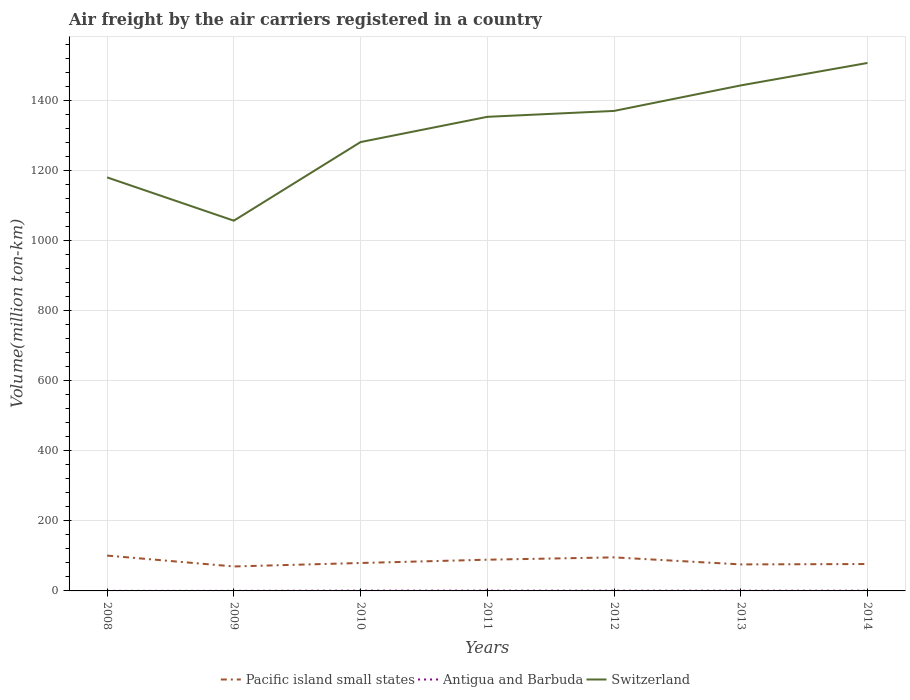Does the line corresponding to Switzerland intersect with the line corresponding to Antigua and Barbuda?
Your answer should be compact. No. Across all years, what is the maximum volume of the air carriers in Switzerland?
Provide a short and direct response. 1057.89. What is the total volume of the air carriers in Switzerland in the graph?
Your answer should be very brief. -100.93. What is the difference between the highest and the second highest volume of the air carriers in Switzerland?
Your response must be concise. 450.6. Is the volume of the air carriers in Antigua and Barbuda strictly greater than the volume of the air carriers in Switzerland over the years?
Your response must be concise. Yes. How many lines are there?
Your answer should be very brief. 3. How many legend labels are there?
Make the answer very short. 3. What is the title of the graph?
Keep it short and to the point. Air freight by the air carriers registered in a country. What is the label or title of the X-axis?
Your response must be concise. Years. What is the label or title of the Y-axis?
Provide a succinct answer. Volume(million ton-km). What is the Volume(million ton-km) in Pacific island small states in 2008?
Give a very brief answer. 100.99. What is the Volume(million ton-km) in Antigua and Barbuda in 2008?
Offer a very short reply. 0.19. What is the Volume(million ton-km) of Switzerland in 2008?
Offer a terse response. 1181.57. What is the Volume(million ton-km) in Pacific island small states in 2009?
Your answer should be very brief. 69.89. What is the Volume(million ton-km) of Antigua and Barbuda in 2009?
Your answer should be very brief. 0.17. What is the Volume(million ton-km) of Switzerland in 2009?
Your response must be concise. 1057.89. What is the Volume(million ton-km) in Pacific island small states in 2010?
Make the answer very short. 79.81. What is the Volume(million ton-km) of Antigua and Barbuda in 2010?
Your answer should be compact. 0.79. What is the Volume(million ton-km) in Switzerland in 2010?
Provide a short and direct response. 1282.5. What is the Volume(million ton-km) in Pacific island small states in 2011?
Make the answer very short. 89.19. What is the Volume(million ton-km) of Antigua and Barbuda in 2011?
Keep it short and to the point. 0.74. What is the Volume(million ton-km) of Switzerland in 2011?
Offer a very short reply. 1354.59. What is the Volume(million ton-km) in Pacific island small states in 2012?
Keep it short and to the point. 95.87. What is the Volume(million ton-km) of Antigua and Barbuda in 2012?
Offer a terse response. 0.65. What is the Volume(million ton-km) of Switzerland in 2012?
Provide a short and direct response. 1371.47. What is the Volume(million ton-km) of Pacific island small states in 2013?
Your answer should be compact. 75.74. What is the Volume(million ton-km) in Antigua and Barbuda in 2013?
Offer a terse response. 0.59. What is the Volume(million ton-km) in Switzerland in 2013?
Ensure brevity in your answer.  1444.37. What is the Volume(million ton-km) in Pacific island small states in 2014?
Make the answer very short. 76.83. What is the Volume(million ton-km) in Antigua and Barbuda in 2014?
Your answer should be very brief. 0.59. What is the Volume(million ton-km) of Switzerland in 2014?
Offer a very short reply. 1508.5. Across all years, what is the maximum Volume(million ton-km) of Pacific island small states?
Provide a succinct answer. 100.99. Across all years, what is the maximum Volume(million ton-km) of Antigua and Barbuda?
Your answer should be very brief. 0.79. Across all years, what is the maximum Volume(million ton-km) in Switzerland?
Give a very brief answer. 1508.5. Across all years, what is the minimum Volume(million ton-km) of Pacific island small states?
Offer a very short reply. 69.89. Across all years, what is the minimum Volume(million ton-km) of Antigua and Barbuda?
Ensure brevity in your answer.  0.17. Across all years, what is the minimum Volume(million ton-km) in Switzerland?
Your answer should be very brief. 1057.89. What is the total Volume(million ton-km) of Pacific island small states in the graph?
Give a very brief answer. 588.33. What is the total Volume(million ton-km) in Antigua and Barbuda in the graph?
Offer a terse response. 3.71. What is the total Volume(million ton-km) of Switzerland in the graph?
Your answer should be very brief. 9200.89. What is the difference between the Volume(million ton-km) in Pacific island small states in 2008 and that in 2009?
Offer a very short reply. 31.1. What is the difference between the Volume(million ton-km) in Antigua and Barbuda in 2008 and that in 2009?
Offer a terse response. 0.03. What is the difference between the Volume(million ton-km) in Switzerland in 2008 and that in 2009?
Keep it short and to the point. 123.67. What is the difference between the Volume(million ton-km) of Pacific island small states in 2008 and that in 2010?
Your answer should be very brief. 21.19. What is the difference between the Volume(million ton-km) of Antigua and Barbuda in 2008 and that in 2010?
Give a very brief answer. -0.59. What is the difference between the Volume(million ton-km) of Switzerland in 2008 and that in 2010?
Keep it short and to the point. -100.93. What is the difference between the Volume(million ton-km) in Pacific island small states in 2008 and that in 2011?
Provide a short and direct response. 11.8. What is the difference between the Volume(million ton-km) of Antigua and Barbuda in 2008 and that in 2011?
Provide a short and direct response. -0.54. What is the difference between the Volume(million ton-km) in Switzerland in 2008 and that in 2011?
Keep it short and to the point. -173.02. What is the difference between the Volume(million ton-km) in Pacific island small states in 2008 and that in 2012?
Give a very brief answer. 5.12. What is the difference between the Volume(million ton-km) of Antigua and Barbuda in 2008 and that in 2012?
Keep it short and to the point. -0.45. What is the difference between the Volume(million ton-km) of Switzerland in 2008 and that in 2012?
Offer a terse response. -189.9. What is the difference between the Volume(million ton-km) of Pacific island small states in 2008 and that in 2013?
Offer a terse response. 25.25. What is the difference between the Volume(million ton-km) of Antigua and Barbuda in 2008 and that in 2013?
Your answer should be very brief. -0.4. What is the difference between the Volume(million ton-km) in Switzerland in 2008 and that in 2013?
Give a very brief answer. -262.81. What is the difference between the Volume(million ton-km) of Pacific island small states in 2008 and that in 2014?
Provide a succinct answer. 24.16. What is the difference between the Volume(million ton-km) in Antigua and Barbuda in 2008 and that in 2014?
Your answer should be very brief. -0.4. What is the difference between the Volume(million ton-km) of Switzerland in 2008 and that in 2014?
Make the answer very short. -326.93. What is the difference between the Volume(million ton-km) of Pacific island small states in 2009 and that in 2010?
Offer a terse response. -9.92. What is the difference between the Volume(million ton-km) of Antigua and Barbuda in 2009 and that in 2010?
Offer a very short reply. -0.62. What is the difference between the Volume(million ton-km) of Switzerland in 2009 and that in 2010?
Your answer should be very brief. -224.6. What is the difference between the Volume(million ton-km) of Pacific island small states in 2009 and that in 2011?
Your answer should be compact. -19.3. What is the difference between the Volume(million ton-km) of Antigua and Barbuda in 2009 and that in 2011?
Offer a very short reply. -0.57. What is the difference between the Volume(million ton-km) of Switzerland in 2009 and that in 2011?
Offer a terse response. -296.7. What is the difference between the Volume(million ton-km) in Pacific island small states in 2009 and that in 2012?
Your answer should be very brief. -25.98. What is the difference between the Volume(million ton-km) of Antigua and Barbuda in 2009 and that in 2012?
Your answer should be compact. -0.48. What is the difference between the Volume(million ton-km) of Switzerland in 2009 and that in 2012?
Your answer should be very brief. -313.58. What is the difference between the Volume(million ton-km) of Pacific island small states in 2009 and that in 2013?
Give a very brief answer. -5.85. What is the difference between the Volume(million ton-km) in Antigua and Barbuda in 2009 and that in 2013?
Offer a very short reply. -0.43. What is the difference between the Volume(million ton-km) of Switzerland in 2009 and that in 2013?
Provide a succinct answer. -386.48. What is the difference between the Volume(million ton-km) of Pacific island small states in 2009 and that in 2014?
Offer a very short reply. -6.94. What is the difference between the Volume(million ton-km) in Antigua and Barbuda in 2009 and that in 2014?
Your response must be concise. -0.43. What is the difference between the Volume(million ton-km) of Switzerland in 2009 and that in 2014?
Provide a succinct answer. -450.6. What is the difference between the Volume(million ton-km) of Pacific island small states in 2010 and that in 2011?
Provide a short and direct response. -9.38. What is the difference between the Volume(million ton-km) of Antigua and Barbuda in 2010 and that in 2011?
Your answer should be compact. 0.05. What is the difference between the Volume(million ton-km) of Switzerland in 2010 and that in 2011?
Your answer should be very brief. -72.09. What is the difference between the Volume(million ton-km) of Pacific island small states in 2010 and that in 2012?
Offer a terse response. -16.07. What is the difference between the Volume(million ton-km) of Antigua and Barbuda in 2010 and that in 2012?
Keep it short and to the point. 0.14. What is the difference between the Volume(million ton-km) in Switzerland in 2010 and that in 2012?
Your response must be concise. -88.97. What is the difference between the Volume(million ton-km) in Pacific island small states in 2010 and that in 2013?
Provide a short and direct response. 4.07. What is the difference between the Volume(million ton-km) of Antigua and Barbuda in 2010 and that in 2013?
Make the answer very short. 0.19. What is the difference between the Volume(million ton-km) in Switzerland in 2010 and that in 2013?
Give a very brief answer. -161.88. What is the difference between the Volume(million ton-km) in Pacific island small states in 2010 and that in 2014?
Give a very brief answer. 2.97. What is the difference between the Volume(million ton-km) in Antigua and Barbuda in 2010 and that in 2014?
Offer a terse response. 0.19. What is the difference between the Volume(million ton-km) of Switzerland in 2010 and that in 2014?
Make the answer very short. -226. What is the difference between the Volume(million ton-km) in Pacific island small states in 2011 and that in 2012?
Ensure brevity in your answer.  -6.68. What is the difference between the Volume(million ton-km) of Antigua and Barbuda in 2011 and that in 2012?
Your answer should be very brief. 0.09. What is the difference between the Volume(million ton-km) of Switzerland in 2011 and that in 2012?
Offer a terse response. -16.88. What is the difference between the Volume(million ton-km) in Pacific island small states in 2011 and that in 2013?
Ensure brevity in your answer.  13.45. What is the difference between the Volume(million ton-km) of Antigua and Barbuda in 2011 and that in 2013?
Provide a short and direct response. 0.15. What is the difference between the Volume(million ton-km) in Switzerland in 2011 and that in 2013?
Ensure brevity in your answer.  -89.78. What is the difference between the Volume(million ton-km) of Pacific island small states in 2011 and that in 2014?
Make the answer very short. 12.36. What is the difference between the Volume(million ton-km) in Antigua and Barbuda in 2011 and that in 2014?
Keep it short and to the point. 0.15. What is the difference between the Volume(million ton-km) in Switzerland in 2011 and that in 2014?
Your answer should be compact. -153.91. What is the difference between the Volume(million ton-km) of Pacific island small states in 2012 and that in 2013?
Your response must be concise. 20.13. What is the difference between the Volume(million ton-km) of Antigua and Barbuda in 2012 and that in 2013?
Your answer should be compact. 0.06. What is the difference between the Volume(million ton-km) of Switzerland in 2012 and that in 2013?
Offer a very short reply. -72.9. What is the difference between the Volume(million ton-km) in Pacific island small states in 2012 and that in 2014?
Provide a succinct answer. 19.04. What is the difference between the Volume(million ton-km) of Antigua and Barbuda in 2012 and that in 2014?
Provide a succinct answer. 0.06. What is the difference between the Volume(million ton-km) in Switzerland in 2012 and that in 2014?
Ensure brevity in your answer.  -137.03. What is the difference between the Volume(million ton-km) of Pacific island small states in 2013 and that in 2014?
Make the answer very short. -1.09. What is the difference between the Volume(million ton-km) in Antigua and Barbuda in 2013 and that in 2014?
Make the answer very short. 0. What is the difference between the Volume(million ton-km) in Switzerland in 2013 and that in 2014?
Your answer should be very brief. -64.12. What is the difference between the Volume(million ton-km) in Pacific island small states in 2008 and the Volume(million ton-km) in Antigua and Barbuda in 2009?
Provide a succinct answer. 100.83. What is the difference between the Volume(million ton-km) in Pacific island small states in 2008 and the Volume(million ton-km) in Switzerland in 2009?
Give a very brief answer. -956.9. What is the difference between the Volume(million ton-km) of Antigua and Barbuda in 2008 and the Volume(million ton-km) of Switzerland in 2009?
Offer a terse response. -1057.7. What is the difference between the Volume(million ton-km) in Pacific island small states in 2008 and the Volume(million ton-km) in Antigua and Barbuda in 2010?
Give a very brief answer. 100.21. What is the difference between the Volume(million ton-km) in Pacific island small states in 2008 and the Volume(million ton-km) in Switzerland in 2010?
Your answer should be very brief. -1181.5. What is the difference between the Volume(million ton-km) in Antigua and Barbuda in 2008 and the Volume(million ton-km) in Switzerland in 2010?
Keep it short and to the point. -1282.3. What is the difference between the Volume(million ton-km) in Pacific island small states in 2008 and the Volume(million ton-km) in Antigua and Barbuda in 2011?
Offer a terse response. 100.26. What is the difference between the Volume(million ton-km) in Pacific island small states in 2008 and the Volume(million ton-km) in Switzerland in 2011?
Provide a succinct answer. -1253.6. What is the difference between the Volume(million ton-km) of Antigua and Barbuda in 2008 and the Volume(million ton-km) of Switzerland in 2011?
Your answer should be very brief. -1354.4. What is the difference between the Volume(million ton-km) in Pacific island small states in 2008 and the Volume(million ton-km) in Antigua and Barbuda in 2012?
Keep it short and to the point. 100.35. What is the difference between the Volume(million ton-km) in Pacific island small states in 2008 and the Volume(million ton-km) in Switzerland in 2012?
Ensure brevity in your answer.  -1270.48. What is the difference between the Volume(million ton-km) in Antigua and Barbuda in 2008 and the Volume(million ton-km) in Switzerland in 2012?
Make the answer very short. -1371.28. What is the difference between the Volume(million ton-km) in Pacific island small states in 2008 and the Volume(million ton-km) in Antigua and Barbuda in 2013?
Make the answer very short. 100.4. What is the difference between the Volume(million ton-km) in Pacific island small states in 2008 and the Volume(million ton-km) in Switzerland in 2013?
Offer a very short reply. -1343.38. What is the difference between the Volume(million ton-km) in Antigua and Barbuda in 2008 and the Volume(million ton-km) in Switzerland in 2013?
Give a very brief answer. -1444.18. What is the difference between the Volume(million ton-km) in Pacific island small states in 2008 and the Volume(million ton-km) in Antigua and Barbuda in 2014?
Keep it short and to the point. 100.4. What is the difference between the Volume(million ton-km) in Pacific island small states in 2008 and the Volume(million ton-km) in Switzerland in 2014?
Give a very brief answer. -1407.5. What is the difference between the Volume(million ton-km) of Antigua and Barbuda in 2008 and the Volume(million ton-km) of Switzerland in 2014?
Your response must be concise. -1508.3. What is the difference between the Volume(million ton-km) in Pacific island small states in 2009 and the Volume(million ton-km) in Antigua and Barbuda in 2010?
Offer a terse response. 69.11. What is the difference between the Volume(million ton-km) in Pacific island small states in 2009 and the Volume(million ton-km) in Switzerland in 2010?
Keep it short and to the point. -1212.61. What is the difference between the Volume(million ton-km) in Antigua and Barbuda in 2009 and the Volume(million ton-km) in Switzerland in 2010?
Make the answer very short. -1282.33. What is the difference between the Volume(million ton-km) of Pacific island small states in 2009 and the Volume(million ton-km) of Antigua and Barbuda in 2011?
Give a very brief answer. 69.15. What is the difference between the Volume(million ton-km) of Pacific island small states in 2009 and the Volume(million ton-km) of Switzerland in 2011?
Keep it short and to the point. -1284.7. What is the difference between the Volume(million ton-km) in Antigua and Barbuda in 2009 and the Volume(million ton-km) in Switzerland in 2011?
Provide a short and direct response. -1354.43. What is the difference between the Volume(million ton-km) in Pacific island small states in 2009 and the Volume(million ton-km) in Antigua and Barbuda in 2012?
Your answer should be very brief. 69.24. What is the difference between the Volume(million ton-km) of Pacific island small states in 2009 and the Volume(million ton-km) of Switzerland in 2012?
Give a very brief answer. -1301.58. What is the difference between the Volume(million ton-km) in Antigua and Barbuda in 2009 and the Volume(million ton-km) in Switzerland in 2012?
Your response must be concise. -1371.31. What is the difference between the Volume(million ton-km) in Pacific island small states in 2009 and the Volume(million ton-km) in Antigua and Barbuda in 2013?
Ensure brevity in your answer.  69.3. What is the difference between the Volume(million ton-km) in Pacific island small states in 2009 and the Volume(million ton-km) in Switzerland in 2013?
Your answer should be compact. -1374.48. What is the difference between the Volume(million ton-km) in Antigua and Barbuda in 2009 and the Volume(million ton-km) in Switzerland in 2013?
Make the answer very short. -1444.21. What is the difference between the Volume(million ton-km) of Pacific island small states in 2009 and the Volume(million ton-km) of Antigua and Barbuda in 2014?
Your response must be concise. 69.3. What is the difference between the Volume(million ton-km) in Pacific island small states in 2009 and the Volume(million ton-km) in Switzerland in 2014?
Your answer should be very brief. -1438.61. What is the difference between the Volume(million ton-km) in Antigua and Barbuda in 2009 and the Volume(million ton-km) in Switzerland in 2014?
Give a very brief answer. -1508.33. What is the difference between the Volume(million ton-km) in Pacific island small states in 2010 and the Volume(million ton-km) in Antigua and Barbuda in 2011?
Ensure brevity in your answer.  79.07. What is the difference between the Volume(million ton-km) in Pacific island small states in 2010 and the Volume(million ton-km) in Switzerland in 2011?
Give a very brief answer. -1274.78. What is the difference between the Volume(million ton-km) in Antigua and Barbuda in 2010 and the Volume(million ton-km) in Switzerland in 2011?
Offer a terse response. -1353.81. What is the difference between the Volume(million ton-km) in Pacific island small states in 2010 and the Volume(million ton-km) in Antigua and Barbuda in 2012?
Your answer should be very brief. 79.16. What is the difference between the Volume(million ton-km) in Pacific island small states in 2010 and the Volume(million ton-km) in Switzerland in 2012?
Offer a very short reply. -1291.66. What is the difference between the Volume(million ton-km) of Antigua and Barbuda in 2010 and the Volume(million ton-km) of Switzerland in 2012?
Ensure brevity in your answer.  -1370.69. What is the difference between the Volume(million ton-km) in Pacific island small states in 2010 and the Volume(million ton-km) in Antigua and Barbuda in 2013?
Offer a terse response. 79.21. What is the difference between the Volume(million ton-km) of Pacific island small states in 2010 and the Volume(million ton-km) of Switzerland in 2013?
Make the answer very short. -1364.57. What is the difference between the Volume(million ton-km) in Antigua and Barbuda in 2010 and the Volume(million ton-km) in Switzerland in 2013?
Offer a very short reply. -1443.59. What is the difference between the Volume(million ton-km) of Pacific island small states in 2010 and the Volume(million ton-km) of Antigua and Barbuda in 2014?
Offer a terse response. 79.22. What is the difference between the Volume(million ton-km) of Pacific island small states in 2010 and the Volume(million ton-km) of Switzerland in 2014?
Give a very brief answer. -1428.69. What is the difference between the Volume(million ton-km) in Antigua and Barbuda in 2010 and the Volume(million ton-km) in Switzerland in 2014?
Offer a very short reply. -1507.71. What is the difference between the Volume(million ton-km) in Pacific island small states in 2011 and the Volume(million ton-km) in Antigua and Barbuda in 2012?
Your answer should be very brief. 88.54. What is the difference between the Volume(million ton-km) in Pacific island small states in 2011 and the Volume(million ton-km) in Switzerland in 2012?
Offer a very short reply. -1282.28. What is the difference between the Volume(million ton-km) in Antigua and Barbuda in 2011 and the Volume(million ton-km) in Switzerland in 2012?
Your answer should be very brief. -1370.73. What is the difference between the Volume(million ton-km) of Pacific island small states in 2011 and the Volume(million ton-km) of Antigua and Barbuda in 2013?
Offer a terse response. 88.6. What is the difference between the Volume(million ton-km) of Pacific island small states in 2011 and the Volume(million ton-km) of Switzerland in 2013?
Offer a very short reply. -1355.18. What is the difference between the Volume(million ton-km) of Antigua and Barbuda in 2011 and the Volume(million ton-km) of Switzerland in 2013?
Offer a very short reply. -1443.64. What is the difference between the Volume(million ton-km) in Pacific island small states in 2011 and the Volume(million ton-km) in Antigua and Barbuda in 2014?
Ensure brevity in your answer.  88.6. What is the difference between the Volume(million ton-km) of Pacific island small states in 2011 and the Volume(million ton-km) of Switzerland in 2014?
Ensure brevity in your answer.  -1419.31. What is the difference between the Volume(million ton-km) of Antigua and Barbuda in 2011 and the Volume(million ton-km) of Switzerland in 2014?
Provide a short and direct response. -1507.76. What is the difference between the Volume(million ton-km) of Pacific island small states in 2012 and the Volume(million ton-km) of Antigua and Barbuda in 2013?
Offer a very short reply. 95.28. What is the difference between the Volume(million ton-km) of Pacific island small states in 2012 and the Volume(million ton-km) of Switzerland in 2013?
Provide a short and direct response. -1348.5. What is the difference between the Volume(million ton-km) of Antigua and Barbuda in 2012 and the Volume(million ton-km) of Switzerland in 2013?
Provide a succinct answer. -1443.73. What is the difference between the Volume(million ton-km) of Pacific island small states in 2012 and the Volume(million ton-km) of Antigua and Barbuda in 2014?
Offer a terse response. 95.28. What is the difference between the Volume(million ton-km) of Pacific island small states in 2012 and the Volume(million ton-km) of Switzerland in 2014?
Make the answer very short. -1412.62. What is the difference between the Volume(million ton-km) of Antigua and Barbuda in 2012 and the Volume(million ton-km) of Switzerland in 2014?
Offer a terse response. -1507.85. What is the difference between the Volume(million ton-km) of Pacific island small states in 2013 and the Volume(million ton-km) of Antigua and Barbuda in 2014?
Offer a terse response. 75.15. What is the difference between the Volume(million ton-km) of Pacific island small states in 2013 and the Volume(million ton-km) of Switzerland in 2014?
Your answer should be compact. -1432.75. What is the difference between the Volume(million ton-km) of Antigua and Barbuda in 2013 and the Volume(million ton-km) of Switzerland in 2014?
Give a very brief answer. -1507.9. What is the average Volume(million ton-km) in Pacific island small states per year?
Your response must be concise. 84.05. What is the average Volume(million ton-km) of Antigua and Barbuda per year?
Your response must be concise. 0.53. What is the average Volume(million ton-km) of Switzerland per year?
Provide a short and direct response. 1314.41. In the year 2008, what is the difference between the Volume(million ton-km) in Pacific island small states and Volume(million ton-km) in Antigua and Barbuda?
Offer a terse response. 100.8. In the year 2008, what is the difference between the Volume(million ton-km) in Pacific island small states and Volume(million ton-km) in Switzerland?
Give a very brief answer. -1080.57. In the year 2008, what is the difference between the Volume(million ton-km) of Antigua and Barbuda and Volume(million ton-km) of Switzerland?
Ensure brevity in your answer.  -1181.37. In the year 2009, what is the difference between the Volume(million ton-km) of Pacific island small states and Volume(million ton-km) of Antigua and Barbuda?
Give a very brief answer. 69.73. In the year 2009, what is the difference between the Volume(million ton-km) in Pacific island small states and Volume(million ton-km) in Switzerland?
Offer a terse response. -988. In the year 2009, what is the difference between the Volume(million ton-km) of Antigua and Barbuda and Volume(million ton-km) of Switzerland?
Your answer should be compact. -1057.73. In the year 2010, what is the difference between the Volume(million ton-km) in Pacific island small states and Volume(million ton-km) in Antigua and Barbuda?
Offer a terse response. 79.02. In the year 2010, what is the difference between the Volume(million ton-km) in Pacific island small states and Volume(million ton-km) in Switzerland?
Your answer should be very brief. -1202.69. In the year 2010, what is the difference between the Volume(million ton-km) in Antigua and Barbuda and Volume(million ton-km) in Switzerland?
Your answer should be compact. -1281.71. In the year 2011, what is the difference between the Volume(million ton-km) of Pacific island small states and Volume(million ton-km) of Antigua and Barbuda?
Your answer should be compact. 88.45. In the year 2011, what is the difference between the Volume(million ton-km) of Pacific island small states and Volume(million ton-km) of Switzerland?
Your answer should be very brief. -1265.4. In the year 2011, what is the difference between the Volume(million ton-km) in Antigua and Barbuda and Volume(million ton-km) in Switzerland?
Keep it short and to the point. -1353.85. In the year 2012, what is the difference between the Volume(million ton-km) in Pacific island small states and Volume(million ton-km) in Antigua and Barbuda?
Your answer should be very brief. 95.23. In the year 2012, what is the difference between the Volume(million ton-km) of Pacific island small states and Volume(million ton-km) of Switzerland?
Ensure brevity in your answer.  -1275.6. In the year 2012, what is the difference between the Volume(million ton-km) in Antigua and Barbuda and Volume(million ton-km) in Switzerland?
Provide a short and direct response. -1370.82. In the year 2013, what is the difference between the Volume(million ton-km) in Pacific island small states and Volume(million ton-km) in Antigua and Barbuda?
Your answer should be compact. 75.15. In the year 2013, what is the difference between the Volume(million ton-km) of Pacific island small states and Volume(million ton-km) of Switzerland?
Your answer should be very brief. -1368.63. In the year 2013, what is the difference between the Volume(million ton-km) of Antigua and Barbuda and Volume(million ton-km) of Switzerland?
Your answer should be very brief. -1443.78. In the year 2014, what is the difference between the Volume(million ton-km) of Pacific island small states and Volume(million ton-km) of Antigua and Barbuda?
Make the answer very short. 76.24. In the year 2014, what is the difference between the Volume(million ton-km) in Pacific island small states and Volume(million ton-km) in Switzerland?
Provide a short and direct response. -1431.66. In the year 2014, what is the difference between the Volume(million ton-km) of Antigua and Barbuda and Volume(million ton-km) of Switzerland?
Offer a terse response. -1507.9. What is the ratio of the Volume(million ton-km) of Pacific island small states in 2008 to that in 2009?
Your response must be concise. 1.45. What is the ratio of the Volume(million ton-km) in Antigua and Barbuda in 2008 to that in 2009?
Your answer should be very brief. 1.17. What is the ratio of the Volume(million ton-km) in Switzerland in 2008 to that in 2009?
Your answer should be very brief. 1.12. What is the ratio of the Volume(million ton-km) of Pacific island small states in 2008 to that in 2010?
Offer a very short reply. 1.27. What is the ratio of the Volume(million ton-km) of Antigua and Barbuda in 2008 to that in 2010?
Your response must be concise. 0.25. What is the ratio of the Volume(million ton-km) in Switzerland in 2008 to that in 2010?
Keep it short and to the point. 0.92. What is the ratio of the Volume(million ton-km) of Pacific island small states in 2008 to that in 2011?
Your response must be concise. 1.13. What is the ratio of the Volume(million ton-km) in Antigua and Barbuda in 2008 to that in 2011?
Ensure brevity in your answer.  0.26. What is the ratio of the Volume(million ton-km) in Switzerland in 2008 to that in 2011?
Provide a succinct answer. 0.87. What is the ratio of the Volume(million ton-km) of Pacific island small states in 2008 to that in 2012?
Offer a terse response. 1.05. What is the ratio of the Volume(million ton-km) in Antigua and Barbuda in 2008 to that in 2012?
Provide a short and direct response. 0.3. What is the ratio of the Volume(million ton-km) of Switzerland in 2008 to that in 2012?
Give a very brief answer. 0.86. What is the ratio of the Volume(million ton-km) of Pacific island small states in 2008 to that in 2013?
Keep it short and to the point. 1.33. What is the ratio of the Volume(million ton-km) in Antigua and Barbuda in 2008 to that in 2013?
Your response must be concise. 0.33. What is the ratio of the Volume(million ton-km) of Switzerland in 2008 to that in 2013?
Provide a succinct answer. 0.82. What is the ratio of the Volume(million ton-km) of Pacific island small states in 2008 to that in 2014?
Ensure brevity in your answer.  1.31. What is the ratio of the Volume(million ton-km) in Antigua and Barbuda in 2008 to that in 2014?
Provide a short and direct response. 0.33. What is the ratio of the Volume(million ton-km) of Switzerland in 2008 to that in 2014?
Provide a succinct answer. 0.78. What is the ratio of the Volume(million ton-km) of Pacific island small states in 2009 to that in 2010?
Offer a very short reply. 0.88. What is the ratio of the Volume(million ton-km) of Antigua and Barbuda in 2009 to that in 2010?
Provide a succinct answer. 0.21. What is the ratio of the Volume(million ton-km) of Switzerland in 2009 to that in 2010?
Ensure brevity in your answer.  0.82. What is the ratio of the Volume(million ton-km) in Pacific island small states in 2009 to that in 2011?
Give a very brief answer. 0.78. What is the ratio of the Volume(million ton-km) in Antigua and Barbuda in 2009 to that in 2011?
Your answer should be very brief. 0.22. What is the ratio of the Volume(million ton-km) in Switzerland in 2009 to that in 2011?
Ensure brevity in your answer.  0.78. What is the ratio of the Volume(million ton-km) of Pacific island small states in 2009 to that in 2012?
Your answer should be very brief. 0.73. What is the ratio of the Volume(million ton-km) in Antigua and Barbuda in 2009 to that in 2012?
Give a very brief answer. 0.25. What is the ratio of the Volume(million ton-km) of Switzerland in 2009 to that in 2012?
Provide a short and direct response. 0.77. What is the ratio of the Volume(million ton-km) of Pacific island small states in 2009 to that in 2013?
Give a very brief answer. 0.92. What is the ratio of the Volume(million ton-km) in Antigua and Barbuda in 2009 to that in 2013?
Keep it short and to the point. 0.28. What is the ratio of the Volume(million ton-km) in Switzerland in 2009 to that in 2013?
Provide a short and direct response. 0.73. What is the ratio of the Volume(million ton-km) of Pacific island small states in 2009 to that in 2014?
Ensure brevity in your answer.  0.91. What is the ratio of the Volume(million ton-km) of Antigua and Barbuda in 2009 to that in 2014?
Provide a short and direct response. 0.28. What is the ratio of the Volume(million ton-km) in Switzerland in 2009 to that in 2014?
Your answer should be very brief. 0.7. What is the ratio of the Volume(million ton-km) of Pacific island small states in 2010 to that in 2011?
Provide a short and direct response. 0.89. What is the ratio of the Volume(million ton-km) in Antigua and Barbuda in 2010 to that in 2011?
Keep it short and to the point. 1.06. What is the ratio of the Volume(million ton-km) of Switzerland in 2010 to that in 2011?
Provide a short and direct response. 0.95. What is the ratio of the Volume(million ton-km) in Pacific island small states in 2010 to that in 2012?
Provide a succinct answer. 0.83. What is the ratio of the Volume(million ton-km) of Antigua and Barbuda in 2010 to that in 2012?
Your answer should be very brief. 1.21. What is the ratio of the Volume(million ton-km) in Switzerland in 2010 to that in 2012?
Your response must be concise. 0.94. What is the ratio of the Volume(million ton-km) of Pacific island small states in 2010 to that in 2013?
Give a very brief answer. 1.05. What is the ratio of the Volume(million ton-km) of Antigua and Barbuda in 2010 to that in 2013?
Provide a short and direct response. 1.32. What is the ratio of the Volume(million ton-km) of Switzerland in 2010 to that in 2013?
Provide a succinct answer. 0.89. What is the ratio of the Volume(million ton-km) in Pacific island small states in 2010 to that in 2014?
Provide a succinct answer. 1.04. What is the ratio of the Volume(million ton-km) in Antigua and Barbuda in 2010 to that in 2014?
Offer a terse response. 1.33. What is the ratio of the Volume(million ton-km) of Switzerland in 2010 to that in 2014?
Your response must be concise. 0.85. What is the ratio of the Volume(million ton-km) in Pacific island small states in 2011 to that in 2012?
Offer a terse response. 0.93. What is the ratio of the Volume(million ton-km) in Antigua and Barbuda in 2011 to that in 2012?
Provide a succinct answer. 1.14. What is the ratio of the Volume(million ton-km) in Pacific island small states in 2011 to that in 2013?
Provide a short and direct response. 1.18. What is the ratio of the Volume(million ton-km) of Antigua and Barbuda in 2011 to that in 2013?
Make the answer very short. 1.25. What is the ratio of the Volume(million ton-km) of Switzerland in 2011 to that in 2013?
Give a very brief answer. 0.94. What is the ratio of the Volume(million ton-km) in Pacific island small states in 2011 to that in 2014?
Offer a very short reply. 1.16. What is the ratio of the Volume(million ton-km) in Antigua and Barbuda in 2011 to that in 2014?
Your answer should be very brief. 1.25. What is the ratio of the Volume(million ton-km) of Switzerland in 2011 to that in 2014?
Ensure brevity in your answer.  0.9. What is the ratio of the Volume(million ton-km) in Pacific island small states in 2012 to that in 2013?
Your response must be concise. 1.27. What is the ratio of the Volume(million ton-km) in Antigua and Barbuda in 2012 to that in 2013?
Give a very brief answer. 1.09. What is the ratio of the Volume(million ton-km) in Switzerland in 2012 to that in 2013?
Provide a succinct answer. 0.95. What is the ratio of the Volume(million ton-km) in Pacific island small states in 2012 to that in 2014?
Your response must be concise. 1.25. What is the ratio of the Volume(million ton-km) of Antigua and Barbuda in 2012 to that in 2014?
Offer a terse response. 1.09. What is the ratio of the Volume(million ton-km) in Switzerland in 2012 to that in 2014?
Your answer should be compact. 0.91. What is the ratio of the Volume(million ton-km) of Pacific island small states in 2013 to that in 2014?
Provide a succinct answer. 0.99. What is the ratio of the Volume(million ton-km) in Switzerland in 2013 to that in 2014?
Provide a short and direct response. 0.96. What is the difference between the highest and the second highest Volume(million ton-km) in Pacific island small states?
Your answer should be compact. 5.12. What is the difference between the highest and the second highest Volume(million ton-km) of Antigua and Barbuda?
Keep it short and to the point. 0.05. What is the difference between the highest and the second highest Volume(million ton-km) of Switzerland?
Give a very brief answer. 64.12. What is the difference between the highest and the lowest Volume(million ton-km) of Pacific island small states?
Ensure brevity in your answer.  31.1. What is the difference between the highest and the lowest Volume(million ton-km) in Antigua and Barbuda?
Your response must be concise. 0.62. What is the difference between the highest and the lowest Volume(million ton-km) in Switzerland?
Your answer should be very brief. 450.6. 